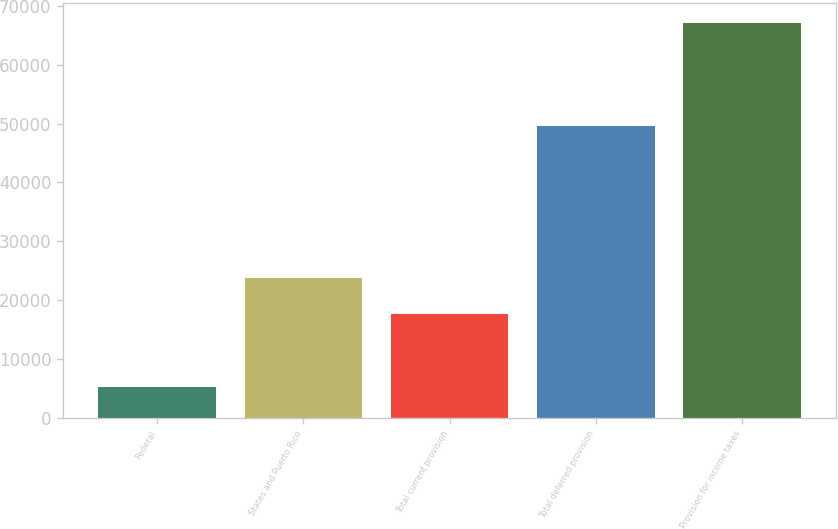<chart> <loc_0><loc_0><loc_500><loc_500><bar_chart><fcel>Federal<fcel>States and Puerto Rico<fcel>Total current provision<fcel>Total deferred provision<fcel>Provision for income taxes<nl><fcel>5157<fcel>23820.2<fcel>17618<fcel>49561<fcel>67179<nl></chart> 